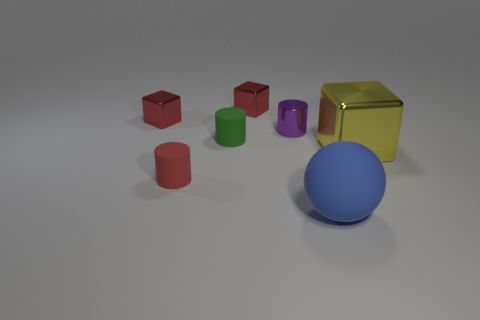Add 3 yellow metallic things. How many objects exist? 10 Subtract all cubes. How many objects are left? 4 Add 2 blue metallic cylinders. How many blue metallic cylinders exist? 2 Subtract 1 blue balls. How many objects are left? 6 Subtract all tiny rubber cylinders. Subtract all green rubber objects. How many objects are left? 4 Add 2 purple metal things. How many purple metal things are left? 3 